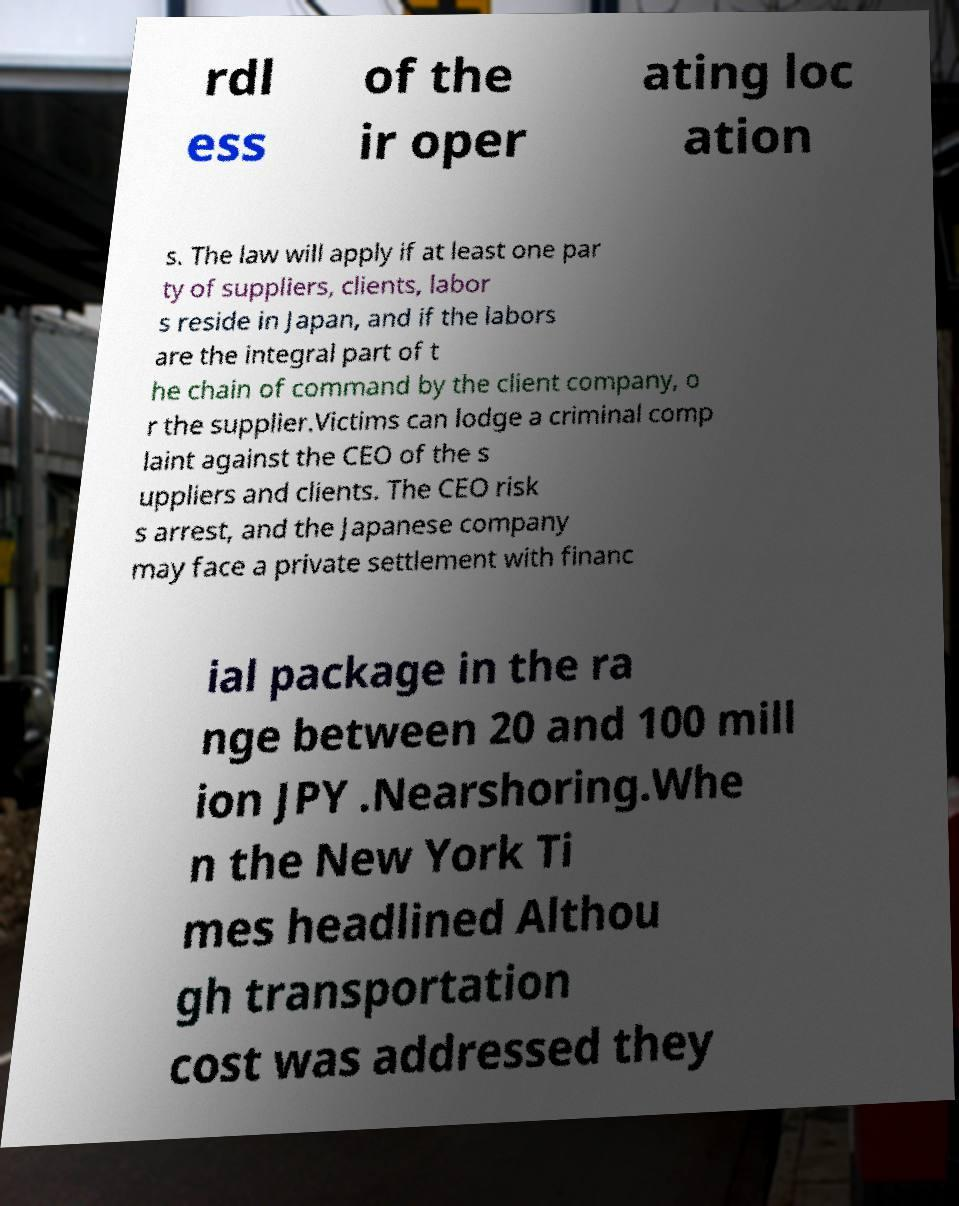Could you assist in decoding the text presented in this image and type it out clearly? rdl ess of the ir oper ating loc ation s. The law will apply if at least one par ty of suppliers, clients, labor s reside in Japan, and if the labors are the integral part of t he chain of command by the client company, o r the supplier.Victims can lodge a criminal comp laint against the CEO of the s uppliers and clients. The CEO risk s arrest, and the Japanese company may face a private settlement with financ ial package in the ra nge between 20 and 100 mill ion JPY .Nearshoring.Whe n the New York Ti mes headlined Althou gh transportation cost was addressed they 